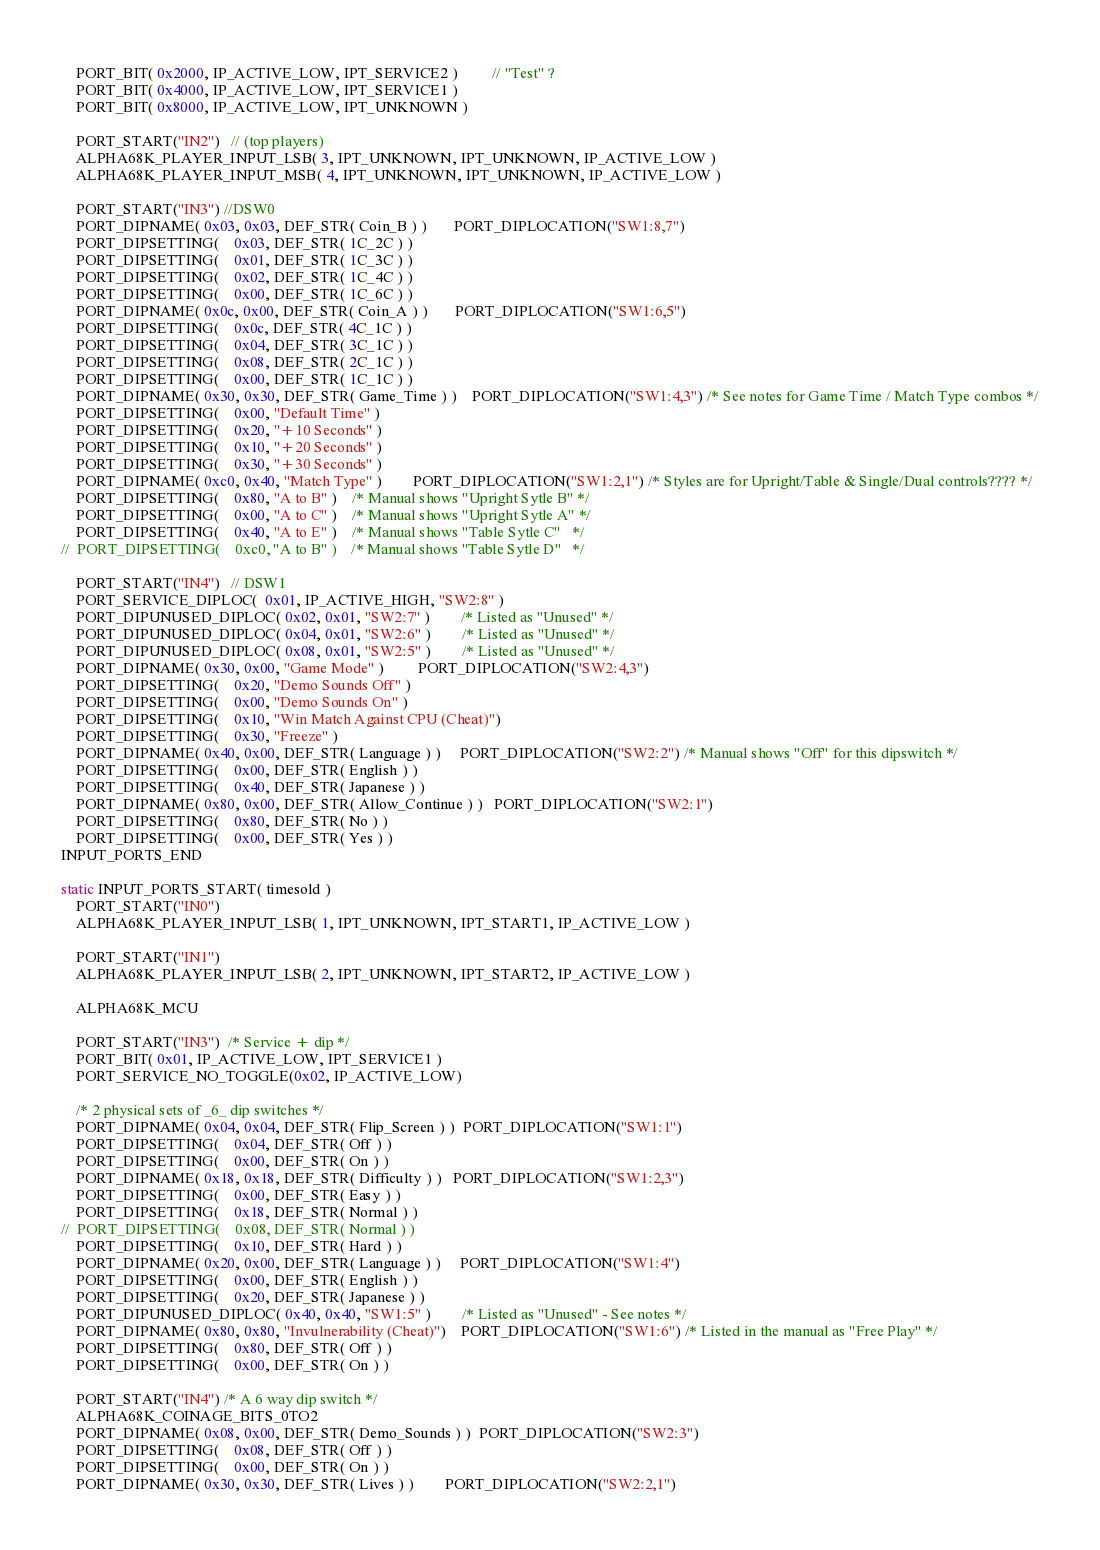<code> <loc_0><loc_0><loc_500><loc_500><_C++_>	PORT_BIT( 0x2000, IP_ACTIVE_LOW, IPT_SERVICE2 )         // "Test" ?
	PORT_BIT( 0x4000, IP_ACTIVE_LOW, IPT_SERVICE1 )
	PORT_BIT( 0x8000, IP_ACTIVE_LOW, IPT_UNKNOWN )

	PORT_START("IN2")   // (top players)
	ALPHA68K_PLAYER_INPUT_LSB( 3, IPT_UNKNOWN, IPT_UNKNOWN, IP_ACTIVE_LOW )
	ALPHA68K_PLAYER_INPUT_MSB( 4, IPT_UNKNOWN, IPT_UNKNOWN, IP_ACTIVE_LOW )

	PORT_START("IN3") //DSW0
	PORT_DIPNAME( 0x03, 0x03, DEF_STR( Coin_B ) )       PORT_DIPLOCATION("SW1:8,7")
	PORT_DIPSETTING(    0x03, DEF_STR( 1C_2C ) )
	PORT_DIPSETTING(    0x01, DEF_STR( 1C_3C ) )
	PORT_DIPSETTING(    0x02, DEF_STR( 1C_4C ) )
	PORT_DIPSETTING(    0x00, DEF_STR( 1C_6C ) )
	PORT_DIPNAME( 0x0c, 0x00, DEF_STR( Coin_A ) )       PORT_DIPLOCATION("SW1:6,5")
	PORT_DIPSETTING(    0x0c, DEF_STR( 4C_1C ) )
	PORT_DIPSETTING(    0x04, DEF_STR( 3C_1C ) )
	PORT_DIPSETTING(    0x08, DEF_STR( 2C_1C ) )
	PORT_DIPSETTING(    0x00, DEF_STR( 1C_1C ) )
	PORT_DIPNAME( 0x30, 0x30, DEF_STR( Game_Time ) )    PORT_DIPLOCATION("SW1:4,3") /* See notes for Game Time / Match Type combos */
	PORT_DIPSETTING(    0x00, "Default Time" )
	PORT_DIPSETTING(    0x20, "+10 Seconds" )
	PORT_DIPSETTING(    0x10, "+20 Seconds" )
	PORT_DIPSETTING(    0x30, "+30 Seconds" )
	PORT_DIPNAME( 0xc0, 0x40, "Match Type" )        PORT_DIPLOCATION("SW1:2,1") /* Styles are for Upright/Table & Single/Dual controls???? */
	PORT_DIPSETTING(    0x80, "A to B" )    /* Manual shows "Upright Sytle B" */
	PORT_DIPSETTING(    0x00, "A to C" )    /* Manual shows "Upright Sytle A" */
	PORT_DIPSETTING(    0x40, "A to E" )    /* Manual shows "Table Sytle C"   */
//  PORT_DIPSETTING(    0xc0, "A to B" )    /* Manual shows "Table Sytle D"   */

	PORT_START("IN4")   // DSW1
	PORT_SERVICE_DIPLOC(  0x01, IP_ACTIVE_HIGH, "SW2:8" )
	PORT_DIPUNUSED_DIPLOC( 0x02, 0x01, "SW2:7" )        /* Listed as "Unused" */
	PORT_DIPUNUSED_DIPLOC( 0x04, 0x01, "SW2:6" )        /* Listed as "Unused" */
	PORT_DIPUNUSED_DIPLOC( 0x08, 0x01, "SW2:5" )        /* Listed as "Unused" */
	PORT_DIPNAME( 0x30, 0x00, "Game Mode" )         PORT_DIPLOCATION("SW2:4,3")
	PORT_DIPSETTING(    0x20, "Demo Sounds Off" )
	PORT_DIPSETTING(    0x00, "Demo Sounds On" )
	PORT_DIPSETTING(    0x10, "Win Match Against CPU (Cheat)")
	PORT_DIPSETTING(    0x30, "Freeze" )
	PORT_DIPNAME( 0x40, 0x00, DEF_STR( Language ) )     PORT_DIPLOCATION("SW2:2") /* Manual shows "Off" for this dipswitch */
	PORT_DIPSETTING(    0x00, DEF_STR( English ) )
	PORT_DIPSETTING(    0x40, DEF_STR( Japanese ) )
	PORT_DIPNAME( 0x80, 0x00, DEF_STR( Allow_Continue ) )   PORT_DIPLOCATION("SW2:1")
	PORT_DIPSETTING(    0x80, DEF_STR( No ) )
	PORT_DIPSETTING(    0x00, DEF_STR( Yes ) )
INPUT_PORTS_END

static INPUT_PORTS_START( timesold )
	PORT_START("IN0")
	ALPHA68K_PLAYER_INPUT_LSB( 1, IPT_UNKNOWN, IPT_START1, IP_ACTIVE_LOW )

	PORT_START("IN1")
	ALPHA68K_PLAYER_INPUT_LSB( 2, IPT_UNKNOWN, IPT_START2, IP_ACTIVE_LOW )

	ALPHA68K_MCU

	PORT_START("IN3")  /* Service + dip */
	PORT_BIT( 0x01, IP_ACTIVE_LOW, IPT_SERVICE1 )
	PORT_SERVICE_NO_TOGGLE(0x02, IP_ACTIVE_LOW)

	/* 2 physical sets of _6_ dip switches */
	PORT_DIPNAME( 0x04, 0x04, DEF_STR( Flip_Screen ) )  PORT_DIPLOCATION("SW1:1")
	PORT_DIPSETTING(    0x04, DEF_STR( Off ) )
	PORT_DIPSETTING(    0x00, DEF_STR( On ) )
	PORT_DIPNAME( 0x18, 0x18, DEF_STR( Difficulty ) )   PORT_DIPLOCATION("SW1:2,3")
	PORT_DIPSETTING(    0x00, DEF_STR( Easy ) )
	PORT_DIPSETTING(    0x18, DEF_STR( Normal ) )
//  PORT_DIPSETTING(    0x08, DEF_STR( Normal ) )
	PORT_DIPSETTING(    0x10, DEF_STR( Hard ) )
	PORT_DIPNAME( 0x20, 0x00, DEF_STR( Language ) )     PORT_DIPLOCATION("SW1:4")
	PORT_DIPSETTING(    0x00, DEF_STR( English ) )
	PORT_DIPSETTING(    0x20, DEF_STR( Japanese ) )
	PORT_DIPUNUSED_DIPLOC( 0x40, 0x40, "SW1:5" )        /* Listed as "Unused" - See notes */
	PORT_DIPNAME( 0x80, 0x80, "Invulnerability (Cheat)")    PORT_DIPLOCATION("SW1:6") /* Listed in the manual as "Free Play" */
	PORT_DIPSETTING(    0x80, DEF_STR( Off ) )
	PORT_DIPSETTING(    0x00, DEF_STR( On ) )

	PORT_START("IN4") /* A 6 way dip switch */
	ALPHA68K_COINAGE_BITS_0TO2
	PORT_DIPNAME( 0x08, 0x00, DEF_STR( Demo_Sounds ) )  PORT_DIPLOCATION("SW2:3")
	PORT_DIPSETTING(    0x08, DEF_STR( Off ) )
	PORT_DIPSETTING(    0x00, DEF_STR( On ) )
	PORT_DIPNAME( 0x30, 0x30, DEF_STR( Lives ) )        PORT_DIPLOCATION("SW2:2,1")</code> 